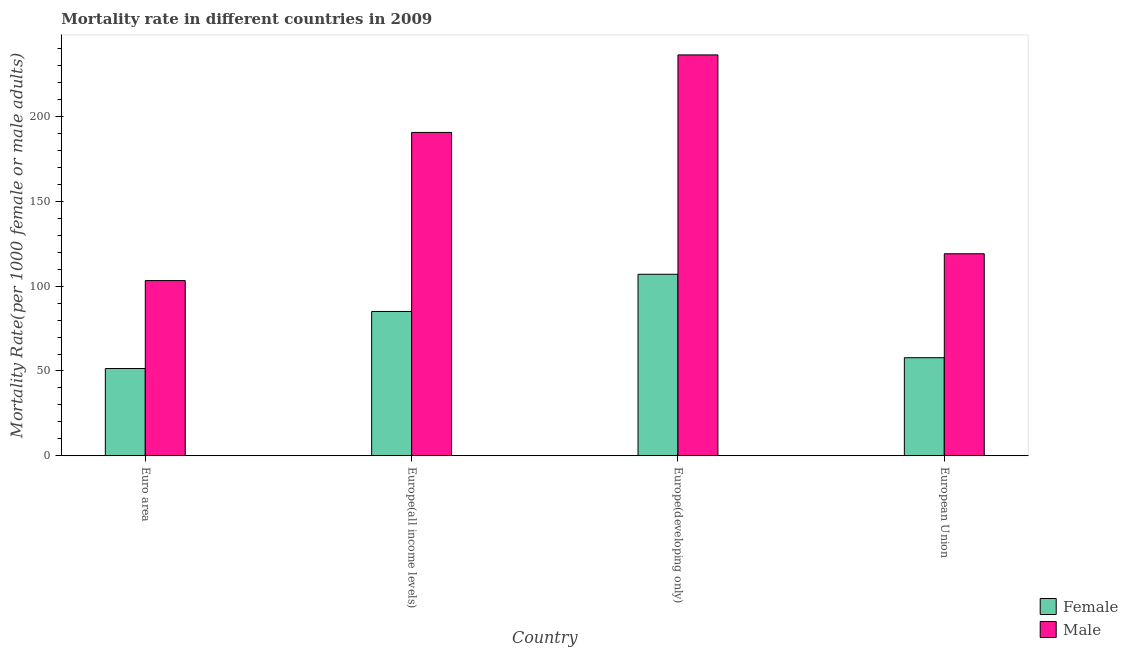How many different coloured bars are there?
Offer a very short reply. 2. Are the number of bars on each tick of the X-axis equal?
Offer a terse response. Yes. How many bars are there on the 4th tick from the left?
Provide a succinct answer. 2. What is the female mortality rate in Europe(developing only)?
Offer a terse response. 107.07. Across all countries, what is the maximum male mortality rate?
Your answer should be compact. 236.48. Across all countries, what is the minimum female mortality rate?
Give a very brief answer. 51.45. In which country was the male mortality rate maximum?
Your answer should be compact. Europe(developing only). In which country was the male mortality rate minimum?
Keep it short and to the point. Euro area. What is the total male mortality rate in the graph?
Offer a very short reply. 649.71. What is the difference between the male mortality rate in Europe(developing only) and that in European Union?
Your answer should be compact. 117.32. What is the difference between the female mortality rate in Europe(all income levels) and the male mortality rate in Europe(developing only)?
Offer a very short reply. -151.36. What is the average female mortality rate per country?
Your response must be concise. 75.37. What is the difference between the male mortality rate and female mortality rate in Europe(developing only)?
Provide a short and direct response. 129.41. In how many countries, is the male mortality rate greater than 230 ?
Ensure brevity in your answer.  1. What is the ratio of the female mortality rate in Euro area to that in Europe(developing only)?
Your answer should be compact. 0.48. Is the difference between the male mortality rate in Europe(developing only) and European Union greater than the difference between the female mortality rate in Europe(developing only) and European Union?
Provide a succinct answer. Yes. What is the difference between the highest and the second highest male mortality rate?
Offer a terse response. 45.73. What is the difference between the highest and the lowest male mortality rate?
Your answer should be compact. 133.15. Is the sum of the male mortality rate in Europe(developing only) and European Union greater than the maximum female mortality rate across all countries?
Your response must be concise. Yes. How many countries are there in the graph?
Your answer should be compact. 4. What is the difference between two consecutive major ticks on the Y-axis?
Keep it short and to the point. 50. Are the values on the major ticks of Y-axis written in scientific E-notation?
Make the answer very short. No. Does the graph contain any zero values?
Provide a succinct answer. No. How are the legend labels stacked?
Give a very brief answer. Vertical. What is the title of the graph?
Keep it short and to the point. Mortality rate in different countries in 2009. Does "From human activities" appear as one of the legend labels in the graph?
Offer a very short reply. No. What is the label or title of the Y-axis?
Provide a short and direct response. Mortality Rate(per 1000 female or male adults). What is the Mortality Rate(per 1000 female or male adults) in Female in Euro area?
Make the answer very short. 51.45. What is the Mortality Rate(per 1000 female or male adults) of Male in Euro area?
Your answer should be very brief. 103.33. What is the Mortality Rate(per 1000 female or male adults) in Female in Europe(all income levels)?
Provide a short and direct response. 85.11. What is the Mortality Rate(per 1000 female or male adults) of Male in Europe(all income levels)?
Make the answer very short. 190.75. What is the Mortality Rate(per 1000 female or male adults) of Female in Europe(developing only)?
Make the answer very short. 107.07. What is the Mortality Rate(per 1000 female or male adults) in Male in Europe(developing only)?
Offer a very short reply. 236.48. What is the Mortality Rate(per 1000 female or male adults) in Female in European Union?
Your answer should be compact. 57.83. What is the Mortality Rate(per 1000 female or male adults) in Male in European Union?
Your response must be concise. 119.16. Across all countries, what is the maximum Mortality Rate(per 1000 female or male adults) of Female?
Make the answer very short. 107.07. Across all countries, what is the maximum Mortality Rate(per 1000 female or male adults) of Male?
Ensure brevity in your answer.  236.48. Across all countries, what is the minimum Mortality Rate(per 1000 female or male adults) in Female?
Your answer should be compact. 51.45. Across all countries, what is the minimum Mortality Rate(per 1000 female or male adults) of Male?
Ensure brevity in your answer.  103.33. What is the total Mortality Rate(per 1000 female or male adults) in Female in the graph?
Provide a short and direct response. 301.46. What is the total Mortality Rate(per 1000 female or male adults) of Male in the graph?
Your response must be concise. 649.71. What is the difference between the Mortality Rate(per 1000 female or male adults) of Female in Euro area and that in Europe(all income levels)?
Your answer should be compact. -33.66. What is the difference between the Mortality Rate(per 1000 female or male adults) of Male in Euro area and that in Europe(all income levels)?
Make the answer very short. -87.42. What is the difference between the Mortality Rate(per 1000 female or male adults) of Female in Euro area and that in Europe(developing only)?
Your answer should be very brief. -55.62. What is the difference between the Mortality Rate(per 1000 female or male adults) of Male in Euro area and that in Europe(developing only)?
Make the answer very short. -133.15. What is the difference between the Mortality Rate(per 1000 female or male adults) of Female in Euro area and that in European Union?
Keep it short and to the point. -6.38. What is the difference between the Mortality Rate(per 1000 female or male adults) in Male in Euro area and that in European Union?
Provide a short and direct response. -15.83. What is the difference between the Mortality Rate(per 1000 female or male adults) in Female in Europe(all income levels) and that in Europe(developing only)?
Your answer should be compact. -21.96. What is the difference between the Mortality Rate(per 1000 female or male adults) in Male in Europe(all income levels) and that in Europe(developing only)?
Offer a terse response. -45.73. What is the difference between the Mortality Rate(per 1000 female or male adults) in Female in Europe(all income levels) and that in European Union?
Provide a succinct answer. 27.29. What is the difference between the Mortality Rate(per 1000 female or male adults) of Male in Europe(all income levels) and that in European Union?
Make the answer very short. 71.59. What is the difference between the Mortality Rate(per 1000 female or male adults) in Female in Europe(developing only) and that in European Union?
Offer a very short reply. 49.24. What is the difference between the Mortality Rate(per 1000 female or male adults) of Male in Europe(developing only) and that in European Union?
Your response must be concise. 117.32. What is the difference between the Mortality Rate(per 1000 female or male adults) of Female in Euro area and the Mortality Rate(per 1000 female or male adults) of Male in Europe(all income levels)?
Your response must be concise. -139.3. What is the difference between the Mortality Rate(per 1000 female or male adults) of Female in Euro area and the Mortality Rate(per 1000 female or male adults) of Male in Europe(developing only)?
Offer a very short reply. -185.03. What is the difference between the Mortality Rate(per 1000 female or male adults) of Female in Euro area and the Mortality Rate(per 1000 female or male adults) of Male in European Union?
Provide a short and direct response. -67.71. What is the difference between the Mortality Rate(per 1000 female or male adults) in Female in Europe(all income levels) and the Mortality Rate(per 1000 female or male adults) in Male in Europe(developing only)?
Your answer should be very brief. -151.36. What is the difference between the Mortality Rate(per 1000 female or male adults) in Female in Europe(all income levels) and the Mortality Rate(per 1000 female or male adults) in Male in European Union?
Keep it short and to the point. -34.04. What is the difference between the Mortality Rate(per 1000 female or male adults) in Female in Europe(developing only) and the Mortality Rate(per 1000 female or male adults) in Male in European Union?
Give a very brief answer. -12.09. What is the average Mortality Rate(per 1000 female or male adults) of Female per country?
Your response must be concise. 75.36. What is the average Mortality Rate(per 1000 female or male adults) of Male per country?
Offer a very short reply. 162.43. What is the difference between the Mortality Rate(per 1000 female or male adults) in Female and Mortality Rate(per 1000 female or male adults) in Male in Euro area?
Provide a succinct answer. -51.88. What is the difference between the Mortality Rate(per 1000 female or male adults) in Female and Mortality Rate(per 1000 female or male adults) in Male in Europe(all income levels)?
Your answer should be very brief. -105.63. What is the difference between the Mortality Rate(per 1000 female or male adults) of Female and Mortality Rate(per 1000 female or male adults) of Male in Europe(developing only)?
Offer a very short reply. -129.41. What is the difference between the Mortality Rate(per 1000 female or male adults) in Female and Mortality Rate(per 1000 female or male adults) in Male in European Union?
Your answer should be compact. -61.33. What is the ratio of the Mortality Rate(per 1000 female or male adults) of Female in Euro area to that in Europe(all income levels)?
Offer a very short reply. 0.6. What is the ratio of the Mortality Rate(per 1000 female or male adults) of Male in Euro area to that in Europe(all income levels)?
Your response must be concise. 0.54. What is the ratio of the Mortality Rate(per 1000 female or male adults) of Female in Euro area to that in Europe(developing only)?
Give a very brief answer. 0.48. What is the ratio of the Mortality Rate(per 1000 female or male adults) in Male in Euro area to that in Europe(developing only)?
Offer a terse response. 0.44. What is the ratio of the Mortality Rate(per 1000 female or male adults) of Female in Euro area to that in European Union?
Give a very brief answer. 0.89. What is the ratio of the Mortality Rate(per 1000 female or male adults) of Male in Euro area to that in European Union?
Provide a succinct answer. 0.87. What is the ratio of the Mortality Rate(per 1000 female or male adults) in Female in Europe(all income levels) to that in Europe(developing only)?
Provide a succinct answer. 0.79. What is the ratio of the Mortality Rate(per 1000 female or male adults) in Male in Europe(all income levels) to that in Europe(developing only)?
Provide a succinct answer. 0.81. What is the ratio of the Mortality Rate(per 1000 female or male adults) in Female in Europe(all income levels) to that in European Union?
Ensure brevity in your answer.  1.47. What is the ratio of the Mortality Rate(per 1000 female or male adults) in Male in Europe(all income levels) to that in European Union?
Keep it short and to the point. 1.6. What is the ratio of the Mortality Rate(per 1000 female or male adults) of Female in Europe(developing only) to that in European Union?
Make the answer very short. 1.85. What is the ratio of the Mortality Rate(per 1000 female or male adults) in Male in Europe(developing only) to that in European Union?
Your answer should be very brief. 1.98. What is the difference between the highest and the second highest Mortality Rate(per 1000 female or male adults) of Female?
Your answer should be very brief. 21.96. What is the difference between the highest and the second highest Mortality Rate(per 1000 female or male adults) of Male?
Ensure brevity in your answer.  45.73. What is the difference between the highest and the lowest Mortality Rate(per 1000 female or male adults) of Female?
Your response must be concise. 55.62. What is the difference between the highest and the lowest Mortality Rate(per 1000 female or male adults) of Male?
Provide a succinct answer. 133.15. 